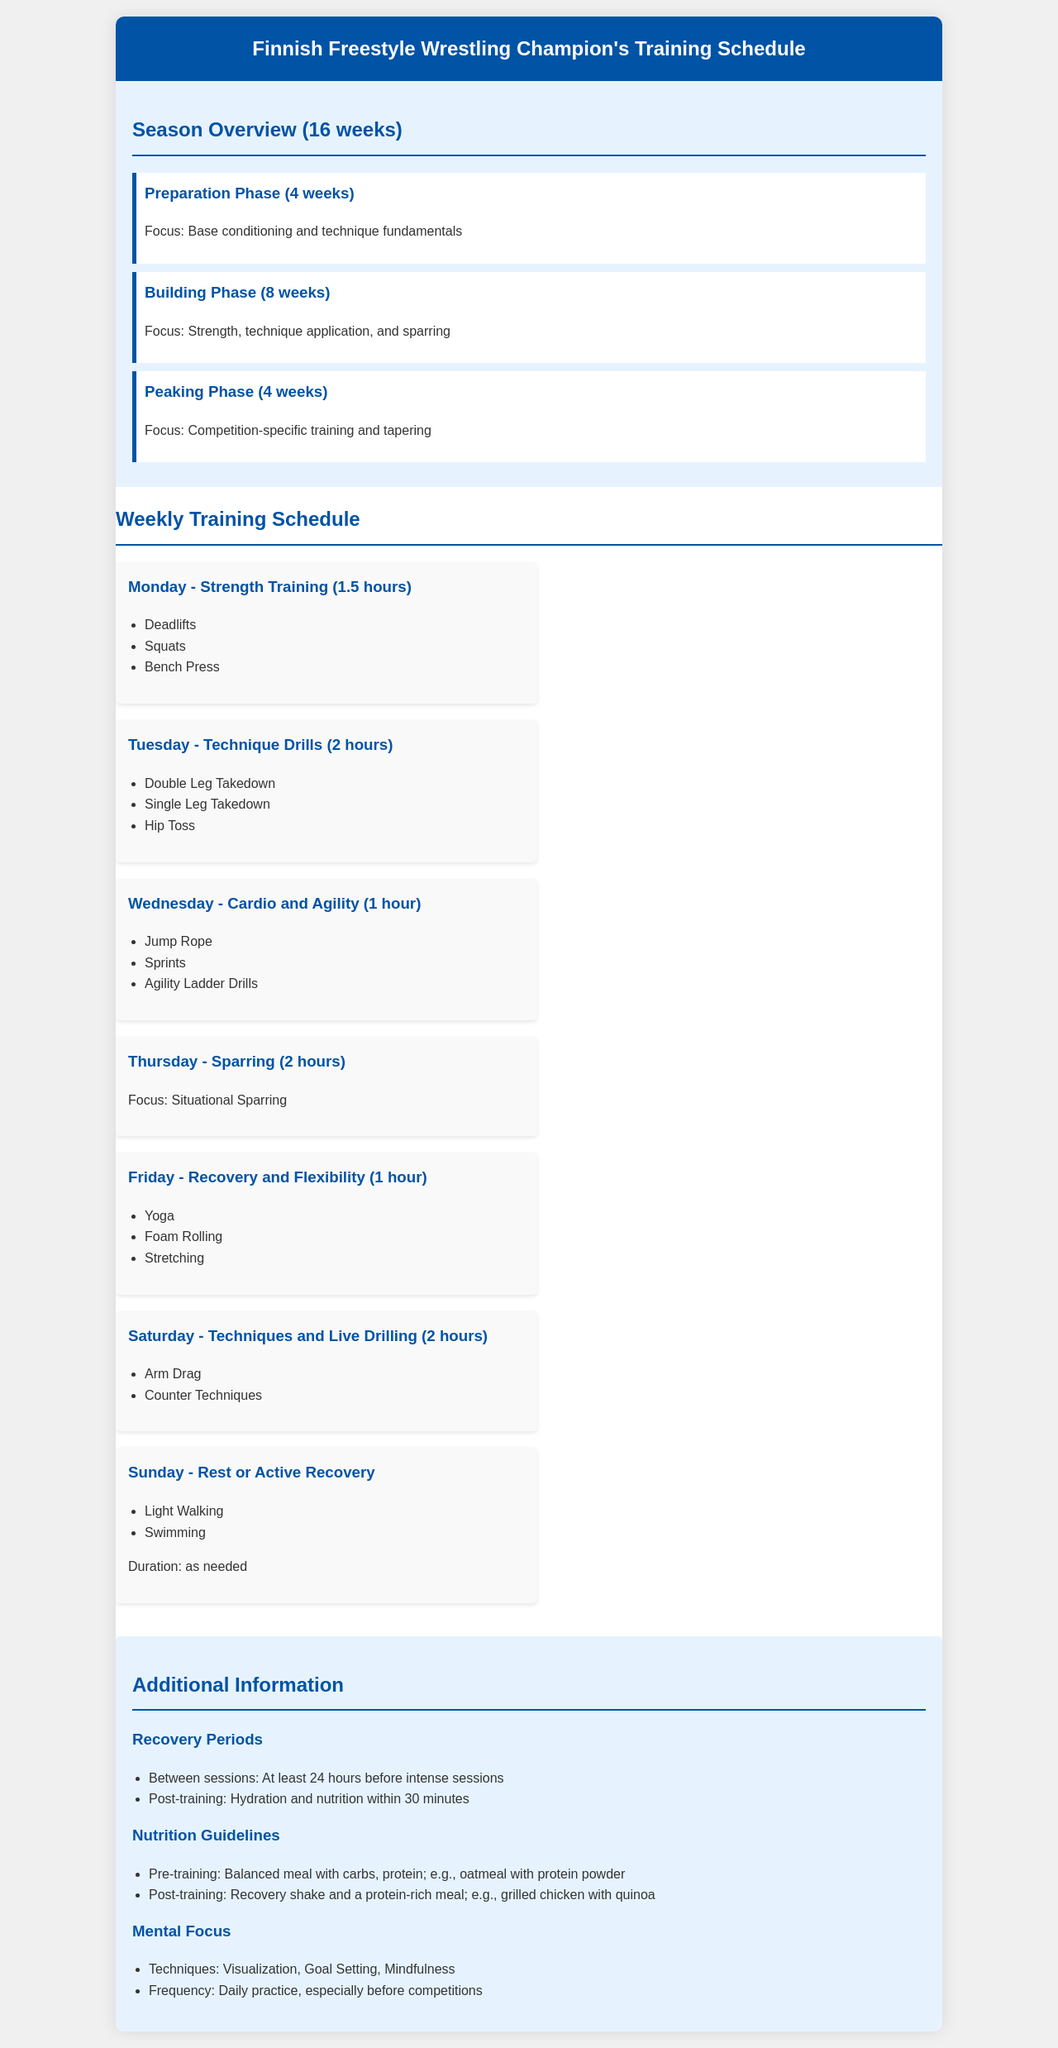What is the duration of the season? The season lasts for 16 weeks as stated in the overview section.
Answer: 16 weeks What is the focus during the Building Phase? The Building Phase emphasizes strength, technique application, and sparring, indicated in the overview.
Answer: Strength, technique application, and sparring How long is the Thursday training session? The duration of the Thursday session is outlined as 2 hours for sparring.
Answer: 2 hours What techniques are practiced on Tuesday? The document specifies the techniques to be practiced on Tuesday, including Double Leg Takedown, Single Leg Takedown, and Hip Toss.
Answer: Double Leg Takedown, Single Leg Takedown, Hip Toss What type of training is emphasized on Fridays? The Friday session focuses on recovery and flexibility, as detailed in the schedule.
Answer: Recovery and Flexibility How long should recovery be between intense sessions? The document mentions at least 24 hours should be allowed for recovery between intense sessions.
Answer: At least 24 hours What is listed as a post-training activity? The post-training activities include hydration and nutrition, as per the additional information section.
Answer: Hydration and nutrition Which day is designated for rest or active recovery? The document indicates that Sunday is designated for rest or active recovery.
Answer: Sunday 